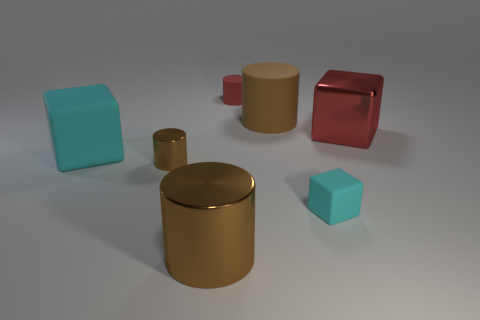The red thing that is the same shape as the tiny brown shiny object is what size?
Provide a succinct answer. Small. Is the number of brown cylinders that are left of the tiny metallic thing greater than the number of small matte cylinders in front of the large cyan matte object?
Ensure brevity in your answer.  No. What material is the block that is to the left of the big red object and on the right side of the big cyan thing?
Provide a short and direct response. Rubber. What is the color of the big metal thing that is the same shape as the tiny brown metal object?
Make the answer very short. Brown. How big is the red matte thing?
Ensure brevity in your answer.  Small. There is a big shiny object behind the small rubber object that is right of the tiny rubber cylinder; what color is it?
Provide a succinct answer. Red. How many tiny matte objects are in front of the red cube and to the left of the brown rubber cylinder?
Provide a short and direct response. 0. Is the number of tiny red things greater than the number of cyan blocks?
Your answer should be compact. No. What is the tiny cube made of?
Offer a very short reply. Rubber. There is a large cylinder to the right of the tiny red object; what number of tiny brown objects are to the right of it?
Offer a terse response. 0. 